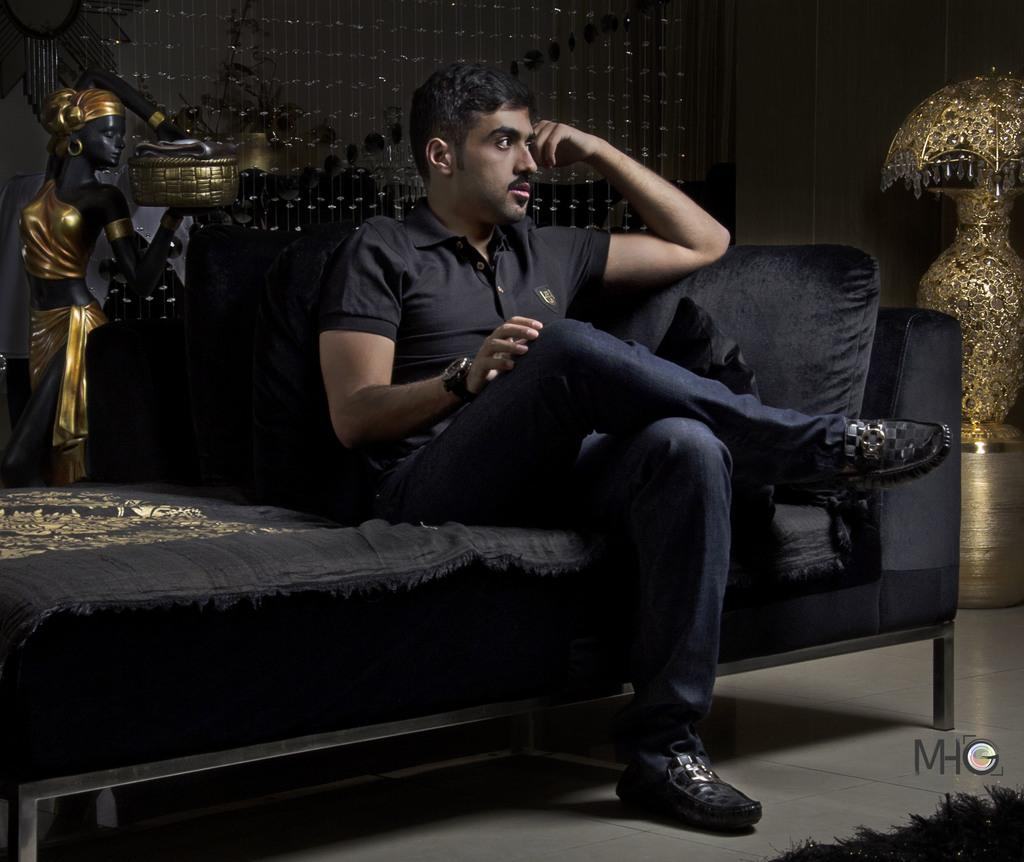What is the person in the image doing? The person is sitting on a sofa in the image. Can you describe any accessories the person is wearing? The person is wearing a watch. What type of surface is visible beneath the person? The image shows a floor. What type of floor covering is present in the image? There is a carpet in the image. What other items can be seen in the image? There are decorative home products visible in the image. What type of letters does the person on the sofa receive in the image? There are no letters visible in the image, and it is not mentioned that the person receives any letters. What message of peace is conveyed by the decorative home products in the image? The decorative home products in the image do not convey any specific message of peace; they are simply decorative items. 